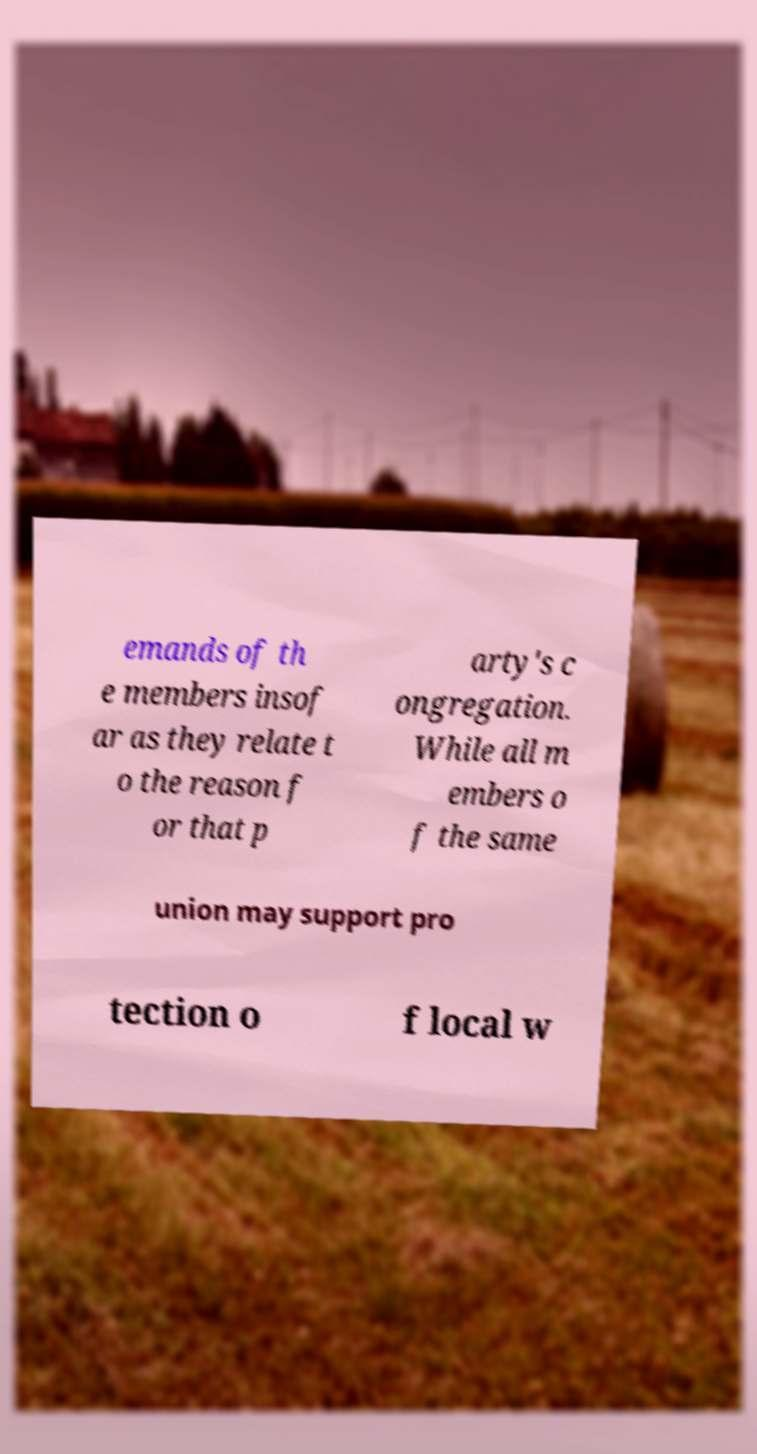Could you extract and type out the text from this image? emands of th e members insof ar as they relate t o the reason f or that p arty's c ongregation. While all m embers o f the same union may support pro tection o f local w 